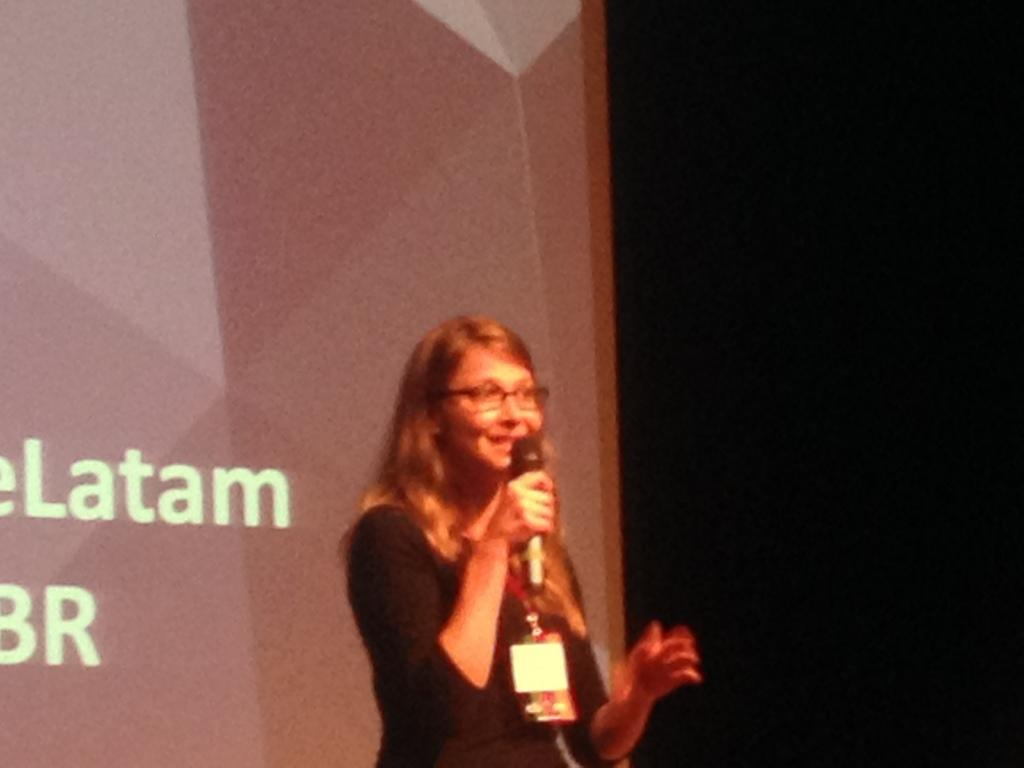What is the main subject of the image? There is a person in the image. What is the person wearing? The person is wearing a black t-shirt. What is the person holding in her hand? The person is holding a microphone in her hand. What can be seen on the right side of the image? There is a black background on the right side of the image. What is displayed on the left side of the image? There is a projector display on the left side of the image. How many crows are sitting on the person's stomach in the image? There are no crows present in the image, and the person's stomach is not visible. What type of donkey can be seen interacting with the projector display in the image? There is no donkey present in the image, and the projector display is not interacting with any animals. 